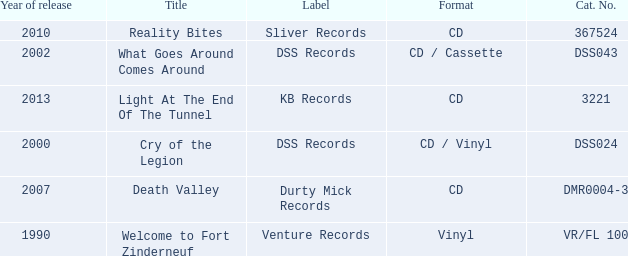What is the total year of release of the title what goes around comes around? 1.0. 